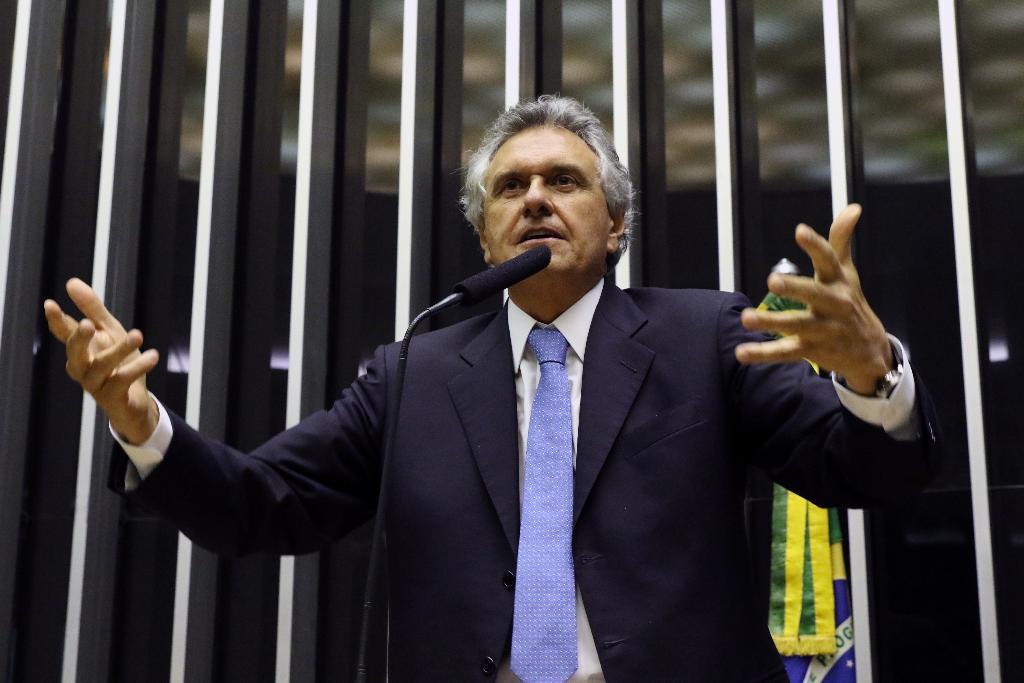Who or what is in the image? There is a person in the image. What is the person wearing? The person is wearing a coat and a blue tie. What is the person doing in the image? The person is standing in front of a microphone. What can be seen in the background of the image? There is a flag and a building in the background of the image. What type of winter activity is the person participating in the image? There is no indication of a winter activity in the image; the person is simply standing in front of a microphone. Can you see the person's heart beating in the image? No, the person's heart is not visible in the image. 